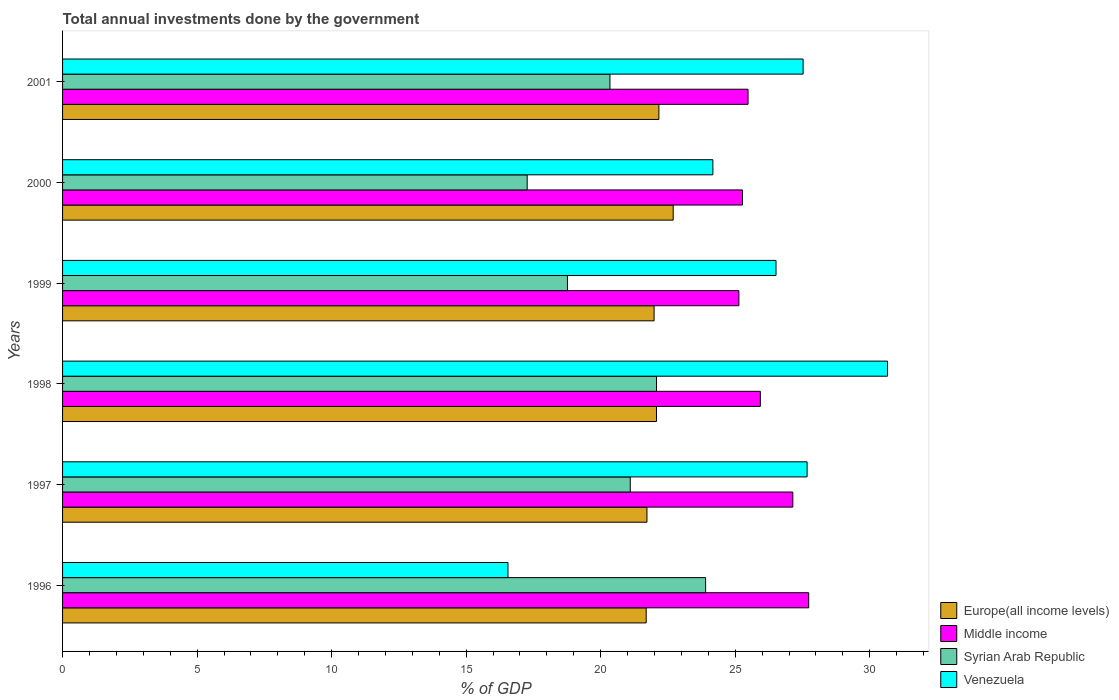How many different coloured bars are there?
Offer a terse response. 4. Are the number of bars on each tick of the Y-axis equal?
Your answer should be very brief. Yes. What is the label of the 6th group of bars from the top?
Your response must be concise. 1996. In how many cases, is the number of bars for a given year not equal to the number of legend labels?
Ensure brevity in your answer.  0. What is the total annual investments done by the government in Middle income in 1997?
Offer a terse response. 27.14. Across all years, what is the maximum total annual investments done by the government in Syrian Arab Republic?
Your answer should be compact. 23.9. Across all years, what is the minimum total annual investments done by the government in Middle income?
Your answer should be very brief. 25.14. In which year was the total annual investments done by the government in Middle income minimum?
Ensure brevity in your answer.  1999. What is the total total annual investments done by the government in Venezuela in the graph?
Provide a short and direct response. 153.1. What is the difference between the total annual investments done by the government in Syrian Arab Republic in 1997 and that in 1998?
Keep it short and to the point. -0.97. What is the difference between the total annual investments done by the government in Venezuela in 1996 and the total annual investments done by the government in Syrian Arab Republic in 1998?
Give a very brief answer. -5.52. What is the average total annual investments done by the government in Venezuela per year?
Provide a short and direct response. 25.52. In the year 2001, what is the difference between the total annual investments done by the government in Syrian Arab Republic and total annual investments done by the government in Middle income?
Give a very brief answer. -5.13. In how many years, is the total annual investments done by the government in Venezuela greater than 27 %?
Give a very brief answer. 3. What is the ratio of the total annual investments done by the government in Venezuela in 1996 to that in 1999?
Keep it short and to the point. 0.62. What is the difference between the highest and the second highest total annual investments done by the government in Europe(all income levels)?
Make the answer very short. 0.53. What is the difference between the highest and the lowest total annual investments done by the government in Syrian Arab Republic?
Provide a short and direct response. 6.63. In how many years, is the total annual investments done by the government in Venezuela greater than the average total annual investments done by the government in Venezuela taken over all years?
Give a very brief answer. 4. Is the sum of the total annual investments done by the government in Venezuela in 1996 and 2000 greater than the maximum total annual investments done by the government in Syrian Arab Republic across all years?
Offer a terse response. Yes. What does the 1st bar from the top in 1999 represents?
Provide a short and direct response. Venezuela. What does the 4th bar from the bottom in 1997 represents?
Give a very brief answer. Venezuela. Are all the bars in the graph horizontal?
Provide a succinct answer. Yes. What is the difference between two consecutive major ticks on the X-axis?
Give a very brief answer. 5. Does the graph contain grids?
Make the answer very short. No. Where does the legend appear in the graph?
Your answer should be compact. Bottom right. How many legend labels are there?
Make the answer very short. 4. What is the title of the graph?
Keep it short and to the point. Total annual investments done by the government. Does "East Asia (all income levels)" appear as one of the legend labels in the graph?
Ensure brevity in your answer.  No. What is the label or title of the X-axis?
Offer a terse response. % of GDP. What is the % of GDP in Europe(all income levels) in 1996?
Provide a short and direct response. 21.69. What is the % of GDP of Middle income in 1996?
Offer a very short reply. 27.73. What is the % of GDP in Syrian Arab Republic in 1996?
Provide a succinct answer. 23.9. What is the % of GDP of Venezuela in 1996?
Offer a very short reply. 16.55. What is the % of GDP in Europe(all income levels) in 1997?
Provide a succinct answer. 21.72. What is the % of GDP in Middle income in 1997?
Give a very brief answer. 27.14. What is the % of GDP in Syrian Arab Republic in 1997?
Provide a succinct answer. 21.1. What is the % of GDP in Venezuela in 1997?
Keep it short and to the point. 27.67. What is the % of GDP of Europe(all income levels) in 1998?
Your answer should be very brief. 22.07. What is the % of GDP in Middle income in 1998?
Provide a short and direct response. 25.93. What is the % of GDP in Syrian Arab Republic in 1998?
Your response must be concise. 22.07. What is the % of GDP in Venezuela in 1998?
Your answer should be very brief. 30.66. What is the % of GDP of Europe(all income levels) in 1999?
Your response must be concise. 21.99. What is the % of GDP of Middle income in 1999?
Your answer should be compact. 25.14. What is the % of GDP of Syrian Arab Republic in 1999?
Provide a succinct answer. 18.77. What is the % of GDP in Venezuela in 1999?
Make the answer very short. 26.52. What is the % of GDP of Europe(all income levels) in 2000?
Ensure brevity in your answer.  22.7. What is the % of GDP of Middle income in 2000?
Keep it short and to the point. 25.27. What is the % of GDP in Syrian Arab Republic in 2000?
Your response must be concise. 17.27. What is the % of GDP of Venezuela in 2000?
Keep it short and to the point. 24.17. What is the % of GDP in Europe(all income levels) in 2001?
Ensure brevity in your answer.  22.16. What is the % of GDP of Middle income in 2001?
Provide a short and direct response. 25.48. What is the % of GDP of Syrian Arab Republic in 2001?
Ensure brevity in your answer.  20.34. What is the % of GDP of Venezuela in 2001?
Provide a succinct answer. 27.52. Across all years, what is the maximum % of GDP in Europe(all income levels)?
Your answer should be very brief. 22.7. Across all years, what is the maximum % of GDP of Middle income?
Provide a short and direct response. 27.73. Across all years, what is the maximum % of GDP in Syrian Arab Republic?
Offer a terse response. 23.9. Across all years, what is the maximum % of GDP in Venezuela?
Provide a succinct answer. 30.66. Across all years, what is the minimum % of GDP of Europe(all income levels)?
Offer a terse response. 21.69. Across all years, what is the minimum % of GDP in Middle income?
Your answer should be very brief. 25.14. Across all years, what is the minimum % of GDP in Syrian Arab Republic?
Offer a terse response. 17.27. Across all years, what is the minimum % of GDP of Venezuela?
Your response must be concise. 16.55. What is the total % of GDP in Europe(all income levels) in the graph?
Offer a very short reply. 132.33. What is the total % of GDP in Middle income in the graph?
Provide a succinct answer. 156.69. What is the total % of GDP of Syrian Arab Republic in the graph?
Ensure brevity in your answer.  123.45. What is the total % of GDP of Venezuela in the graph?
Offer a terse response. 153.1. What is the difference between the % of GDP of Europe(all income levels) in 1996 and that in 1997?
Keep it short and to the point. -0.03. What is the difference between the % of GDP in Middle income in 1996 and that in 1997?
Ensure brevity in your answer.  0.59. What is the difference between the % of GDP in Venezuela in 1996 and that in 1997?
Keep it short and to the point. -11.12. What is the difference between the % of GDP in Europe(all income levels) in 1996 and that in 1998?
Offer a terse response. -0.38. What is the difference between the % of GDP in Middle income in 1996 and that in 1998?
Provide a short and direct response. 1.8. What is the difference between the % of GDP in Syrian Arab Republic in 1996 and that in 1998?
Make the answer very short. 1.83. What is the difference between the % of GDP in Venezuela in 1996 and that in 1998?
Ensure brevity in your answer.  -14.11. What is the difference between the % of GDP of Europe(all income levels) in 1996 and that in 1999?
Your answer should be compact. -0.29. What is the difference between the % of GDP in Middle income in 1996 and that in 1999?
Your answer should be very brief. 2.6. What is the difference between the % of GDP of Syrian Arab Republic in 1996 and that in 1999?
Provide a succinct answer. 5.13. What is the difference between the % of GDP in Venezuela in 1996 and that in 1999?
Give a very brief answer. -9.96. What is the difference between the % of GDP of Europe(all income levels) in 1996 and that in 2000?
Provide a succinct answer. -1. What is the difference between the % of GDP of Middle income in 1996 and that in 2000?
Provide a succinct answer. 2.46. What is the difference between the % of GDP in Syrian Arab Republic in 1996 and that in 2000?
Keep it short and to the point. 6.63. What is the difference between the % of GDP in Venezuela in 1996 and that in 2000?
Keep it short and to the point. -7.62. What is the difference between the % of GDP of Europe(all income levels) in 1996 and that in 2001?
Give a very brief answer. -0.47. What is the difference between the % of GDP of Middle income in 1996 and that in 2001?
Your answer should be very brief. 2.25. What is the difference between the % of GDP of Syrian Arab Republic in 1996 and that in 2001?
Give a very brief answer. 3.56. What is the difference between the % of GDP of Venezuela in 1996 and that in 2001?
Offer a terse response. -10.97. What is the difference between the % of GDP of Europe(all income levels) in 1997 and that in 1998?
Make the answer very short. -0.35. What is the difference between the % of GDP of Middle income in 1997 and that in 1998?
Your answer should be compact. 1.21. What is the difference between the % of GDP of Syrian Arab Republic in 1997 and that in 1998?
Offer a very short reply. -0.97. What is the difference between the % of GDP of Venezuela in 1997 and that in 1998?
Your answer should be very brief. -2.99. What is the difference between the % of GDP of Europe(all income levels) in 1997 and that in 1999?
Offer a very short reply. -0.27. What is the difference between the % of GDP in Middle income in 1997 and that in 1999?
Your response must be concise. 2.01. What is the difference between the % of GDP of Syrian Arab Republic in 1997 and that in 1999?
Your answer should be compact. 2.33. What is the difference between the % of GDP of Venezuela in 1997 and that in 1999?
Provide a short and direct response. 1.16. What is the difference between the % of GDP of Europe(all income levels) in 1997 and that in 2000?
Keep it short and to the point. -0.98. What is the difference between the % of GDP of Middle income in 1997 and that in 2000?
Your answer should be compact. 1.87. What is the difference between the % of GDP in Syrian Arab Republic in 1997 and that in 2000?
Ensure brevity in your answer.  3.83. What is the difference between the % of GDP of Venezuela in 1997 and that in 2000?
Offer a terse response. 3.5. What is the difference between the % of GDP in Europe(all income levels) in 1997 and that in 2001?
Provide a succinct answer. -0.44. What is the difference between the % of GDP of Middle income in 1997 and that in 2001?
Keep it short and to the point. 1.66. What is the difference between the % of GDP of Syrian Arab Republic in 1997 and that in 2001?
Ensure brevity in your answer.  0.76. What is the difference between the % of GDP of Venezuela in 1997 and that in 2001?
Your answer should be very brief. 0.15. What is the difference between the % of GDP in Europe(all income levels) in 1998 and that in 1999?
Make the answer very short. 0.09. What is the difference between the % of GDP in Middle income in 1998 and that in 1999?
Give a very brief answer. 0.8. What is the difference between the % of GDP in Syrian Arab Republic in 1998 and that in 1999?
Make the answer very short. 3.31. What is the difference between the % of GDP of Venezuela in 1998 and that in 1999?
Offer a terse response. 4.14. What is the difference between the % of GDP of Europe(all income levels) in 1998 and that in 2000?
Offer a terse response. -0.62. What is the difference between the % of GDP in Middle income in 1998 and that in 2000?
Offer a very short reply. 0.66. What is the difference between the % of GDP of Syrian Arab Republic in 1998 and that in 2000?
Provide a succinct answer. 4.81. What is the difference between the % of GDP in Venezuela in 1998 and that in 2000?
Give a very brief answer. 6.49. What is the difference between the % of GDP of Europe(all income levels) in 1998 and that in 2001?
Give a very brief answer. -0.09. What is the difference between the % of GDP in Middle income in 1998 and that in 2001?
Ensure brevity in your answer.  0.46. What is the difference between the % of GDP in Syrian Arab Republic in 1998 and that in 2001?
Provide a succinct answer. 1.73. What is the difference between the % of GDP of Venezuela in 1998 and that in 2001?
Your answer should be compact. 3.14. What is the difference between the % of GDP of Europe(all income levels) in 1999 and that in 2000?
Make the answer very short. -0.71. What is the difference between the % of GDP in Middle income in 1999 and that in 2000?
Your answer should be very brief. -0.13. What is the difference between the % of GDP in Syrian Arab Republic in 1999 and that in 2000?
Your response must be concise. 1.5. What is the difference between the % of GDP in Venezuela in 1999 and that in 2000?
Offer a very short reply. 2.35. What is the difference between the % of GDP of Europe(all income levels) in 1999 and that in 2001?
Ensure brevity in your answer.  -0.18. What is the difference between the % of GDP in Middle income in 1999 and that in 2001?
Provide a short and direct response. -0.34. What is the difference between the % of GDP in Syrian Arab Republic in 1999 and that in 2001?
Keep it short and to the point. -1.58. What is the difference between the % of GDP in Venezuela in 1999 and that in 2001?
Make the answer very short. -1.01. What is the difference between the % of GDP in Europe(all income levels) in 2000 and that in 2001?
Offer a terse response. 0.53. What is the difference between the % of GDP of Middle income in 2000 and that in 2001?
Make the answer very short. -0.21. What is the difference between the % of GDP in Syrian Arab Republic in 2000 and that in 2001?
Make the answer very short. -3.08. What is the difference between the % of GDP of Venezuela in 2000 and that in 2001?
Offer a terse response. -3.35. What is the difference between the % of GDP in Europe(all income levels) in 1996 and the % of GDP in Middle income in 1997?
Offer a terse response. -5.45. What is the difference between the % of GDP of Europe(all income levels) in 1996 and the % of GDP of Syrian Arab Republic in 1997?
Offer a very short reply. 0.59. What is the difference between the % of GDP in Europe(all income levels) in 1996 and the % of GDP in Venezuela in 1997?
Your answer should be compact. -5.98. What is the difference between the % of GDP in Middle income in 1996 and the % of GDP in Syrian Arab Republic in 1997?
Offer a terse response. 6.63. What is the difference between the % of GDP of Middle income in 1996 and the % of GDP of Venezuela in 1997?
Keep it short and to the point. 0.06. What is the difference between the % of GDP in Syrian Arab Republic in 1996 and the % of GDP in Venezuela in 1997?
Your answer should be compact. -3.77. What is the difference between the % of GDP in Europe(all income levels) in 1996 and the % of GDP in Middle income in 1998?
Your answer should be compact. -4.24. What is the difference between the % of GDP of Europe(all income levels) in 1996 and the % of GDP of Syrian Arab Republic in 1998?
Keep it short and to the point. -0.38. What is the difference between the % of GDP of Europe(all income levels) in 1996 and the % of GDP of Venezuela in 1998?
Give a very brief answer. -8.97. What is the difference between the % of GDP of Middle income in 1996 and the % of GDP of Syrian Arab Republic in 1998?
Keep it short and to the point. 5.66. What is the difference between the % of GDP in Middle income in 1996 and the % of GDP in Venezuela in 1998?
Keep it short and to the point. -2.93. What is the difference between the % of GDP of Syrian Arab Republic in 1996 and the % of GDP of Venezuela in 1998?
Provide a succinct answer. -6.76. What is the difference between the % of GDP in Europe(all income levels) in 1996 and the % of GDP in Middle income in 1999?
Keep it short and to the point. -3.44. What is the difference between the % of GDP of Europe(all income levels) in 1996 and the % of GDP of Syrian Arab Republic in 1999?
Provide a short and direct response. 2.93. What is the difference between the % of GDP in Europe(all income levels) in 1996 and the % of GDP in Venezuela in 1999?
Provide a succinct answer. -4.83. What is the difference between the % of GDP in Middle income in 1996 and the % of GDP in Syrian Arab Republic in 1999?
Give a very brief answer. 8.97. What is the difference between the % of GDP of Middle income in 1996 and the % of GDP of Venezuela in 1999?
Your answer should be very brief. 1.21. What is the difference between the % of GDP in Syrian Arab Republic in 1996 and the % of GDP in Venezuela in 1999?
Your answer should be very brief. -2.62. What is the difference between the % of GDP in Europe(all income levels) in 1996 and the % of GDP in Middle income in 2000?
Offer a terse response. -3.58. What is the difference between the % of GDP of Europe(all income levels) in 1996 and the % of GDP of Syrian Arab Republic in 2000?
Make the answer very short. 4.42. What is the difference between the % of GDP of Europe(all income levels) in 1996 and the % of GDP of Venezuela in 2000?
Your answer should be very brief. -2.48. What is the difference between the % of GDP of Middle income in 1996 and the % of GDP of Syrian Arab Republic in 2000?
Provide a succinct answer. 10.46. What is the difference between the % of GDP of Middle income in 1996 and the % of GDP of Venezuela in 2000?
Offer a terse response. 3.56. What is the difference between the % of GDP of Syrian Arab Republic in 1996 and the % of GDP of Venezuela in 2000?
Your answer should be very brief. -0.27. What is the difference between the % of GDP in Europe(all income levels) in 1996 and the % of GDP in Middle income in 2001?
Give a very brief answer. -3.79. What is the difference between the % of GDP of Europe(all income levels) in 1996 and the % of GDP of Syrian Arab Republic in 2001?
Your answer should be very brief. 1.35. What is the difference between the % of GDP in Europe(all income levels) in 1996 and the % of GDP in Venezuela in 2001?
Your answer should be very brief. -5.83. What is the difference between the % of GDP of Middle income in 1996 and the % of GDP of Syrian Arab Republic in 2001?
Your answer should be compact. 7.39. What is the difference between the % of GDP in Middle income in 1996 and the % of GDP in Venezuela in 2001?
Provide a succinct answer. 0.21. What is the difference between the % of GDP of Syrian Arab Republic in 1996 and the % of GDP of Venezuela in 2001?
Make the answer very short. -3.62. What is the difference between the % of GDP of Europe(all income levels) in 1997 and the % of GDP of Middle income in 1998?
Your response must be concise. -4.21. What is the difference between the % of GDP in Europe(all income levels) in 1997 and the % of GDP in Syrian Arab Republic in 1998?
Provide a short and direct response. -0.35. What is the difference between the % of GDP in Europe(all income levels) in 1997 and the % of GDP in Venezuela in 1998?
Give a very brief answer. -8.94. What is the difference between the % of GDP of Middle income in 1997 and the % of GDP of Syrian Arab Republic in 1998?
Offer a terse response. 5.07. What is the difference between the % of GDP of Middle income in 1997 and the % of GDP of Venezuela in 1998?
Your answer should be compact. -3.52. What is the difference between the % of GDP of Syrian Arab Republic in 1997 and the % of GDP of Venezuela in 1998?
Give a very brief answer. -9.56. What is the difference between the % of GDP in Europe(all income levels) in 1997 and the % of GDP in Middle income in 1999?
Ensure brevity in your answer.  -3.42. What is the difference between the % of GDP of Europe(all income levels) in 1997 and the % of GDP of Syrian Arab Republic in 1999?
Ensure brevity in your answer.  2.95. What is the difference between the % of GDP in Europe(all income levels) in 1997 and the % of GDP in Venezuela in 1999?
Your answer should be very brief. -4.8. What is the difference between the % of GDP in Middle income in 1997 and the % of GDP in Syrian Arab Republic in 1999?
Provide a succinct answer. 8.38. What is the difference between the % of GDP of Middle income in 1997 and the % of GDP of Venezuela in 1999?
Make the answer very short. 0.62. What is the difference between the % of GDP of Syrian Arab Republic in 1997 and the % of GDP of Venezuela in 1999?
Provide a short and direct response. -5.42. What is the difference between the % of GDP in Europe(all income levels) in 1997 and the % of GDP in Middle income in 2000?
Your answer should be very brief. -3.55. What is the difference between the % of GDP of Europe(all income levels) in 1997 and the % of GDP of Syrian Arab Republic in 2000?
Keep it short and to the point. 4.45. What is the difference between the % of GDP in Europe(all income levels) in 1997 and the % of GDP in Venezuela in 2000?
Offer a very short reply. -2.45. What is the difference between the % of GDP in Middle income in 1997 and the % of GDP in Syrian Arab Republic in 2000?
Make the answer very short. 9.87. What is the difference between the % of GDP of Middle income in 1997 and the % of GDP of Venezuela in 2000?
Offer a terse response. 2.97. What is the difference between the % of GDP in Syrian Arab Republic in 1997 and the % of GDP in Venezuela in 2000?
Give a very brief answer. -3.07. What is the difference between the % of GDP in Europe(all income levels) in 1997 and the % of GDP in Middle income in 2001?
Ensure brevity in your answer.  -3.76. What is the difference between the % of GDP of Europe(all income levels) in 1997 and the % of GDP of Syrian Arab Republic in 2001?
Your answer should be compact. 1.38. What is the difference between the % of GDP of Europe(all income levels) in 1997 and the % of GDP of Venezuela in 2001?
Give a very brief answer. -5.8. What is the difference between the % of GDP of Middle income in 1997 and the % of GDP of Syrian Arab Republic in 2001?
Ensure brevity in your answer.  6.8. What is the difference between the % of GDP in Middle income in 1997 and the % of GDP in Venezuela in 2001?
Your answer should be compact. -0.38. What is the difference between the % of GDP of Syrian Arab Republic in 1997 and the % of GDP of Venezuela in 2001?
Provide a short and direct response. -6.42. What is the difference between the % of GDP of Europe(all income levels) in 1998 and the % of GDP of Middle income in 1999?
Your answer should be very brief. -3.06. What is the difference between the % of GDP of Europe(all income levels) in 1998 and the % of GDP of Syrian Arab Republic in 1999?
Give a very brief answer. 3.31. What is the difference between the % of GDP of Europe(all income levels) in 1998 and the % of GDP of Venezuela in 1999?
Ensure brevity in your answer.  -4.44. What is the difference between the % of GDP in Middle income in 1998 and the % of GDP in Syrian Arab Republic in 1999?
Your response must be concise. 7.17. What is the difference between the % of GDP of Middle income in 1998 and the % of GDP of Venezuela in 1999?
Keep it short and to the point. -0.58. What is the difference between the % of GDP of Syrian Arab Republic in 1998 and the % of GDP of Venezuela in 1999?
Your answer should be very brief. -4.44. What is the difference between the % of GDP in Europe(all income levels) in 1998 and the % of GDP in Middle income in 2000?
Offer a terse response. -3.2. What is the difference between the % of GDP in Europe(all income levels) in 1998 and the % of GDP in Syrian Arab Republic in 2000?
Your answer should be very brief. 4.81. What is the difference between the % of GDP of Europe(all income levels) in 1998 and the % of GDP of Venezuela in 2000?
Your answer should be very brief. -2.1. What is the difference between the % of GDP in Middle income in 1998 and the % of GDP in Syrian Arab Republic in 2000?
Give a very brief answer. 8.67. What is the difference between the % of GDP of Middle income in 1998 and the % of GDP of Venezuela in 2000?
Keep it short and to the point. 1.76. What is the difference between the % of GDP in Syrian Arab Republic in 1998 and the % of GDP in Venezuela in 2000?
Provide a succinct answer. -2.1. What is the difference between the % of GDP of Europe(all income levels) in 1998 and the % of GDP of Middle income in 2001?
Provide a succinct answer. -3.4. What is the difference between the % of GDP in Europe(all income levels) in 1998 and the % of GDP in Syrian Arab Republic in 2001?
Offer a very short reply. 1.73. What is the difference between the % of GDP in Europe(all income levels) in 1998 and the % of GDP in Venezuela in 2001?
Offer a terse response. -5.45. What is the difference between the % of GDP in Middle income in 1998 and the % of GDP in Syrian Arab Republic in 2001?
Your answer should be compact. 5.59. What is the difference between the % of GDP of Middle income in 1998 and the % of GDP of Venezuela in 2001?
Your response must be concise. -1.59. What is the difference between the % of GDP in Syrian Arab Republic in 1998 and the % of GDP in Venezuela in 2001?
Ensure brevity in your answer.  -5.45. What is the difference between the % of GDP in Europe(all income levels) in 1999 and the % of GDP in Middle income in 2000?
Provide a succinct answer. -3.29. What is the difference between the % of GDP of Europe(all income levels) in 1999 and the % of GDP of Syrian Arab Republic in 2000?
Your answer should be compact. 4.72. What is the difference between the % of GDP in Europe(all income levels) in 1999 and the % of GDP in Venezuela in 2000?
Provide a succinct answer. -2.18. What is the difference between the % of GDP of Middle income in 1999 and the % of GDP of Syrian Arab Republic in 2000?
Your response must be concise. 7.87. What is the difference between the % of GDP in Middle income in 1999 and the % of GDP in Venezuela in 2000?
Make the answer very short. 0.97. What is the difference between the % of GDP of Syrian Arab Republic in 1999 and the % of GDP of Venezuela in 2000?
Offer a terse response. -5.41. What is the difference between the % of GDP of Europe(all income levels) in 1999 and the % of GDP of Middle income in 2001?
Offer a terse response. -3.49. What is the difference between the % of GDP of Europe(all income levels) in 1999 and the % of GDP of Syrian Arab Republic in 2001?
Your answer should be very brief. 1.64. What is the difference between the % of GDP in Europe(all income levels) in 1999 and the % of GDP in Venezuela in 2001?
Offer a very short reply. -5.54. What is the difference between the % of GDP of Middle income in 1999 and the % of GDP of Syrian Arab Republic in 2001?
Your response must be concise. 4.79. What is the difference between the % of GDP in Middle income in 1999 and the % of GDP in Venezuela in 2001?
Provide a short and direct response. -2.39. What is the difference between the % of GDP in Syrian Arab Republic in 1999 and the % of GDP in Venezuela in 2001?
Make the answer very short. -8.76. What is the difference between the % of GDP in Europe(all income levels) in 2000 and the % of GDP in Middle income in 2001?
Make the answer very short. -2.78. What is the difference between the % of GDP of Europe(all income levels) in 2000 and the % of GDP of Syrian Arab Republic in 2001?
Give a very brief answer. 2.35. What is the difference between the % of GDP of Europe(all income levels) in 2000 and the % of GDP of Venezuela in 2001?
Offer a terse response. -4.83. What is the difference between the % of GDP in Middle income in 2000 and the % of GDP in Syrian Arab Republic in 2001?
Ensure brevity in your answer.  4.93. What is the difference between the % of GDP of Middle income in 2000 and the % of GDP of Venezuela in 2001?
Keep it short and to the point. -2.25. What is the difference between the % of GDP in Syrian Arab Republic in 2000 and the % of GDP in Venezuela in 2001?
Make the answer very short. -10.26. What is the average % of GDP of Europe(all income levels) per year?
Your answer should be very brief. 22.06. What is the average % of GDP in Middle income per year?
Your answer should be compact. 26.12. What is the average % of GDP in Syrian Arab Republic per year?
Your answer should be compact. 20.58. What is the average % of GDP of Venezuela per year?
Provide a short and direct response. 25.52. In the year 1996, what is the difference between the % of GDP of Europe(all income levels) and % of GDP of Middle income?
Make the answer very short. -6.04. In the year 1996, what is the difference between the % of GDP in Europe(all income levels) and % of GDP in Syrian Arab Republic?
Ensure brevity in your answer.  -2.21. In the year 1996, what is the difference between the % of GDP in Europe(all income levels) and % of GDP in Venezuela?
Your response must be concise. 5.14. In the year 1996, what is the difference between the % of GDP of Middle income and % of GDP of Syrian Arab Republic?
Offer a very short reply. 3.83. In the year 1996, what is the difference between the % of GDP in Middle income and % of GDP in Venezuela?
Provide a short and direct response. 11.18. In the year 1996, what is the difference between the % of GDP of Syrian Arab Republic and % of GDP of Venezuela?
Give a very brief answer. 7.35. In the year 1997, what is the difference between the % of GDP of Europe(all income levels) and % of GDP of Middle income?
Make the answer very short. -5.42. In the year 1997, what is the difference between the % of GDP in Europe(all income levels) and % of GDP in Syrian Arab Republic?
Provide a short and direct response. 0.62. In the year 1997, what is the difference between the % of GDP in Europe(all income levels) and % of GDP in Venezuela?
Offer a very short reply. -5.95. In the year 1997, what is the difference between the % of GDP in Middle income and % of GDP in Syrian Arab Republic?
Provide a succinct answer. 6.04. In the year 1997, what is the difference between the % of GDP in Middle income and % of GDP in Venezuela?
Provide a short and direct response. -0.53. In the year 1997, what is the difference between the % of GDP of Syrian Arab Republic and % of GDP of Venezuela?
Give a very brief answer. -6.57. In the year 1998, what is the difference between the % of GDP in Europe(all income levels) and % of GDP in Middle income?
Your answer should be very brief. -3.86. In the year 1998, what is the difference between the % of GDP of Europe(all income levels) and % of GDP of Syrian Arab Republic?
Your answer should be compact. -0. In the year 1998, what is the difference between the % of GDP in Europe(all income levels) and % of GDP in Venezuela?
Make the answer very short. -8.59. In the year 1998, what is the difference between the % of GDP in Middle income and % of GDP in Syrian Arab Republic?
Offer a terse response. 3.86. In the year 1998, what is the difference between the % of GDP of Middle income and % of GDP of Venezuela?
Give a very brief answer. -4.73. In the year 1998, what is the difference between the % of GDP in Syrian Arab Republic and % of GDP in Venezuela?
Your answer should be very brief. -8.59. In the year 1999, what is the difference between the % of GDP in Europe(all income levels) and % of GDP in Middle income?
Offer a very short reply. -3.15. In the year 1999, what is the difference between the % of GDP in Europe(all income levels) and % of GDP in Syrian Arab Republic?
Keep it short and to the point. 3.22. In the year 1999, what is the difference between the % of GDP of Europe(all income levels) and % of GDP of Venezuela?
Make the answer very short. -4.53. In the year 1999, what is the difference between the % of GDP in Middle income and % of GDP in Syrian Arab Republic?
Make the answer very short. 6.37. In the year 1999, what is the difference between the % of GDP in Middle income and % of GDP in Venezuela?
Your answer should be compact. -1.38. In the year 1999, what is the difference between the % of GDP of Syrian Arab Republic and % of GDP of Venezuela?
Offer a terse response. -7.75. In the year 2000, what is the difference between the % of GDP of Europe(all income levels) and % of GDP of Middle income?
Your response must be concise. -2.58. In the year 2000, what is the difference between the % of GDP in Europe(all income levels) and % of GDP in Syrian Arab Republic?
Give a very brief answer. 5.43. In the year 2000, what is the difference between the % of GDP in Europe(all income levels) and % of GDP in Venezuela?
Make the answer very short. -1.47. In the year 2000, what is the difference between the % of GDP in Middle income and % of GDP in Syrian Arab Republic?
Ensure brevity in your answer.  8. In the year 2000, what is the difference between the % of GDP in Middle income and % of GDP in Venezuela?
Keep it short and to the point. 1.1. In the year 2000, what is the difference between the % of GDP of Syrian Arab Republic and % of GDP of Venezuela?
Keep it short and to the point. -6.9. In the year 2001, what is the difference between the % of GDP of Europe(all income levels) and % of GDP of Middle income?
Your response must be concise. -3.31. In the year 2001, what is the difference between the % of GDP of Europe(all income levels) and % of GDP of Syrian Arab Republic?
Ensure brevity in your answer.  1.82. In the year 2001, what is the difference between the % of GDP in Europe(all income levels) and % of GDP in Venezuela?
Offer a very short reply. -5.36. In the year 2001, what is the difference between the % of GDP of Middle income and % of GDP of Syrian Arab Republic?
Your answer should be compact. 5.13. In the year 2001, what is the difference between the % of GDP of Middle income and % of GDP of Venezuela?
Offer a terse response. -2.05. In the year 2001, what is the difference between the % of GDP of Syrian Arab Republic and % of GDP of Venezuela?
Keep it short and to the point. -7.18. What is the ratio of the % of GDP in Middle income in 1996 to that in 1997?
Provide a succinct answer. 1.02. What is the ratio of the % of GDP of Syrian Arab Republic in 1996 to that in 1997?
Ensure brevity in your answer.  1.13. What is the ratio of the % of GDP of Venezuela in 1996 to that in 1997?
Provide a succinct answer. 0.6. What is the ratio of the % of GDP of Europe(all income levels) in 1996 to that in 1998?
Make the answer very short. 0.98. What is the ratio of the % of GDP of Middle income in 1996 to that in 1998?
Provide a short and direct response. 1.07. What is the ratio of the % of GDP of Syrian Arab Republic in 1996 to that in 1998?
Give a very brief answer. 1.08. What is the ratio of the % of GDP of Venezuela in 1996 to that in 1998?
Ensure brevity in your answer.  0.54. What is the ratio of the % of GDP of Europe(all income levels) in 1996 to that in 1999?
Your answer should be very brief. 0.99. What is the ratio of the % of GDP of Middle income in 1996 to that in 1999?
Provide a short and direct response. 1.1. What is the ratio of the % of GDP in Syrian Arab Republic in 1996 to that in 1999?
Provide a short and direct response. 1.27. What is the ratio of the % of GDP of Venezuela in 1996 to that in 1999?
Your answer should be very brief. 0.62. What is the ratio of the % of GDP in Europe(all income levels) in 1996 to that in 2000?
Your answer should be compact. 0.96. What is the ratio of the % of GDP in Middle income in 1996 to that in 2000?
Give a very brief answer. 1.1. What is the ratio of the % of GDP of Syrian Arab Republic in 1996 to that in 2000?
Keep it short and to the point. 1.38. What is the ratio of the % of GDP of Venezuela in 1996 to that in 2000?
Provide a short and direct response. 0.68. What is the ratio of the % of GDP of Europe(all income levels) in 1996 to that in 2001?
Your answer should be very brief. 0.98. What is the ratio of the % of GDP of Middle income in 1996 to that in 2001?
Ensure brevity in your answer.  1.09. What is the ratio of the % of GDP of Syrian Arab Republic in 1996 to that in 2001?
Your answer should be very brief. 1.17. What is the ratio of the % of GDP in Venezuela in 1996 to that in 2001?
Provide a succinct answer. 0.6. What is the ratio of the % of GDP in Middle income in 1997 to that in 1998?
Your answer should be very brief. 1.05. What is the ratio of the % of GDP in Syrian Arab Republic in 1997 to that in 1998?
Provide a short and direct response. 0.96. What is the ratio of the % of GDP in Venezuela in 1997 to that in 1998?
Your answer should be compact. 0.9. What is the ratio of the % of GDP of Europe(all income levels) in 1997 to that in 1999?
Offer a very short reply. 0.99. What is the ratio of the % of GDP in Middle income in 1997 to that in 1999?
Provide a short and direct response. 1.08. What is the ratio of the % of GDP in Syrian Arab Republic in 1997 to that in 1999?
Offer a very short reply. 1.12. What is the ratio of the % of GDP of Venezuela in 1997 to that in 1999?
Your answer should be very brief. 1.04. What is the ratio of the % of GDP in Europe(all income levels) in 1997 to that in 2000?
Offer a very short reply. 0.96. What is the ratio of the % of GDP in Middle income in 1997 to that in 2000?
Your response must be concise. 1.07. What is the ratio of the % of GDP of Syrian Arab Republic in 1997 to that in 2000?
Offer a terse response. 1.22. What is the ratio of the % of GDP in Venezuela in 1997 to that in 2000?
Provide a succinct answer. 1.14. What is the ratio of the % of GDP of Middle income in 1997 to that in 2001?
Give a very brief answer. 1.07. What is the ratio of the % of GDP of Syrian Arab Republic in 1997 to that in 2001?
Your answer should be very brief. 1.04. What is the ratio of the % of GDP in Venezuela in 1997 to that in 2001?
Provide a short and direct response. 1.01. What is the ratio of the % of GDP of Middle income in 1998 to that in 1999?
Offer a very short reply. 1.03. What is the ratio of the % of GDP of Syrian Arab Republic in 1998 to that in 1999?
Offer a very short reply. 1.18. What is the ratio of the % of GDP in Venezuela in 1998 to that in 1999?
Offer a terse response. 1.16. What is the ratio of the % of GDP of Europe(all income levels) in 1998 to that in 2000?
Keep it short and to the point. 0.97. What is the ratio of the % of GDP in Middle income in 1998 to that in 2000?
Your answer should be compact. 1.03. What is the ratio of the % of GDP in Syrian Arab Republic in 1998 to that in 2000?
Your answer should be compact. 1.28. What is the ratio of the % of GDP in Venezuela in 1998 to that in 2000?
Give a very brief answer. 1.27. What is the ratio of the % of GDP of Middle income in 1998 to that in 2001?
Offer a very short reply. 1.02. What is the ratio of the % of GDP of Syrian Arab Republic in 1998 to that in 2001?
Provide a short and direct response. 1.08. What is the ratio of the % of GDP of Venezuela in 1998 to that in 2001?
Make the answer very short. 1.11. What is the ratio of the % of GDP of Europe(all income levels) in 1999 to that in 2000?
Offer a very short reply. 0.97. What is the ratio of the % of GDP in Syrian Arab Republic in 1999 to that in 2000?
Your response must be concise. 1.09. What is the ratio of the % of GDP of Venezuela in 1999 to that in 2000?
Your answer should be compact. 1.1. What is the ratio of the % of GDP of Europe(all income levels) in 1999 to that in 2001?
Your answer should be very brief. 0.99. What is the ratio of the % of GDP in Middle income in 1999 to that in 2001?
Provide a short and direct response. 0.99. What is the ratio of the % of GDP in Syrian Arab Republic in 1999 to that in 2001?
Provide a short and direct response. 0.92. What is the ratio of the % of GDP of Venezuela in 1999 to that in 2001?
Keep it short and to the point. 0.96. What is the ratio of the % of GDP in Europe(all income levels) in 2000 to that in 2001?
Give a very brief answer. 1.02. What is the ratio of the % of GDP of Middle income in 2000 to that in 2001?
Your answer should be compact. 0.99. What is the ratio of the % of GDP of Syrian Arab Republic in 2000 to that in 2001?
Make the answer very short. 0.85. What is the ratio of the % of GDP in Venezuela in 2000 to that in 2001?
Make the answer very short. 0.88. What is the difference between the highest and the second highest % of GDP of Europe(all income levels)?
Your response must be concise. 0.53. What is the difference between the highest and the second highest % of GDP of Middle income?
Make the answer very short. 0.59. What is the difference between the highest and the second highest % of GDP of Syrian Arab Republic?
Give a very brief answer. 1.83. What is the difference between the highest and the second highest % of GDP of Venezuela?
Your response must be concise. 2.99. What is the difference between the highest and the lowest % of GDP of Middle income?
Provide a short and direct response. 2.6. What is the difference between the highest and the lowest % of GDP of Syrian Arab Republic?
Give a very brief answer. 6.63. What is the difference between the highest and the lowest % of GDP of Venezuela?
Offer a terse response. 14.11. 